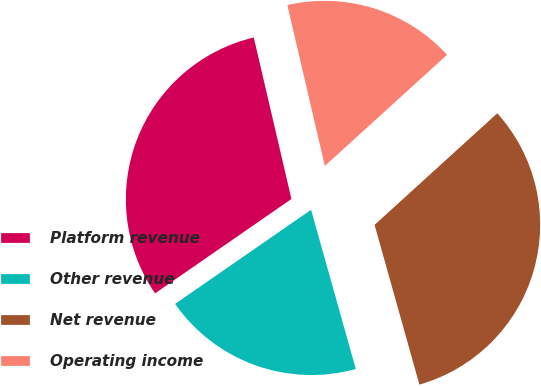<chart> <loc_0><loc_0><loc_500><loc_500><pie_chart><fcel>Platform revenue<fcel>Other revenue<fcel>Net revenue<fcel>Operating income<nl><fcel>30.99%<fcel>19.72%<fcel>32.39%<fcel>16.9%<nl></chart> 